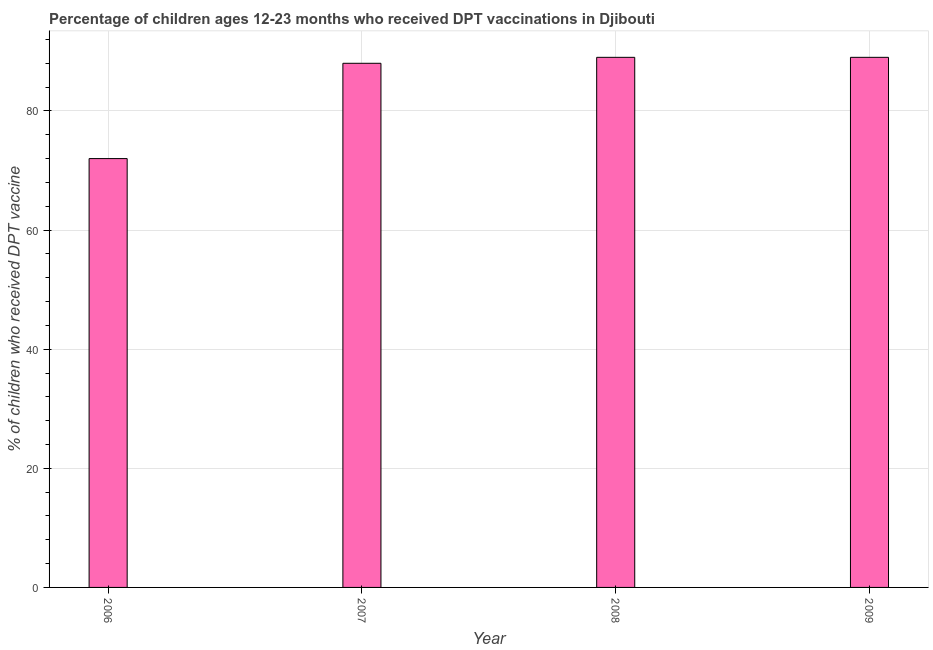Does the graph contain any zero values?
Your answer should be compact. No. Does the graph contain grids?
Your answer should be very brief. Yes. What is the title of the graph?
Provide a short and direct response. Percentage of children ages 12-23 months who received DPT vaccinations in Djibouti. What is the label or title of the X-axis?
Offer a terse response. Year. What is the label or title of the Y-axis?
Offer a very short reply. % of children who received DPT vaccine. What is the percentage of children who received dpt vaccine in 2009?
Give a very brief answer. 89. Across all years, what is the maximum percentage of children who received dpt vaccine?
Your response must be concise. 89. In which year was the percentage of children who received dpt vaccine maximum?
Your answer should be compact. 2008. In which year was the percentage of children who received dpt vaccine minimum?
Keep it short and to the point. 2006. What is the sum of the percentage of children who received dpt vaccine?
Keep it short and to the point. 338. What is the median percentage of children who received dpt vaccine?
Offer a terse response. 88.5. In how many years, is the percentage of children who received dpt vaccine greater than 36 %?
Offer a very short reply. 4. Do a majority of the years between 2008 and 2007 (inclusive) have percentage of children who received dpt vaccine greater than 68 %?
Provide a short and direct response. No. What is the ratio of the percentage of children who received dpt vaccine in 2006 to that in 2008?
Keep it short and to the point. 0.81. Is the difference between the percentage of children who received dpt vaccine in 2006 and 2008 greater than the difference between any two years?
Offer a very short reply. Yes. What is the difference between the highest and the second highest percentage of children who received dpt vaccine?
Your answer should be very brief. 0. Is the sum of the percentage of children who received dpt vaccine in 2007 and 2009 greater than the maximum percentage of children who received dpt vaccine across all years?
Offer a very short reply. Yes. What is the difference between the highest and the lowest percentage of children who received dpt vaccine?
Your answer should be compact. 17. In how many years, is the percentage of children who received dpt vaccine greater than the average percentage of children who received dpt vaccine taken over all years?
Offer a terse response. 3. How many bars are there?
Provide a short and direct response. 4. What is the % of children who received DPT vaccine of 2006?
Your answer should be very brief. 72. What is the % of children who received DPT vaccine in 2007?
Your answer should be compact. 88. What is the % of children who received DPT vaccine of 2008?
Your answer should be compact. 89. What is the % of children who received DPT vaccine of 2009?
Keep it short and to the point. 89. What is the difference between the % of children who received DPT vaccine in 2006 and 2008?
Your answer should be compact. -17. What is the difference between the % of children who received DPT vaccine in 2007 and 2009?
Your response must be concise. -1. What is the difference between the % of children who received DPT vaccine in 2008 and 2009?
Make the answer very short. 0. What is the ratio of the % of children who received DPT vaccine in 2006 to that in 2007?
Offer a terse response. 0.82. What is the ratio of the % of children who received DPT vaccine in 2006 to that in 2008?
Keep it short and to the point. 0.81. What is the ratio of the % of children who received DPT vaccine in 2006 to that in 2009?
Ensure brevity in your answer.  0.81. What is the ratio of the % of children who received DPT vaccine in 2008 to that in 2009?
Ensure brevity in your answer.  1. 